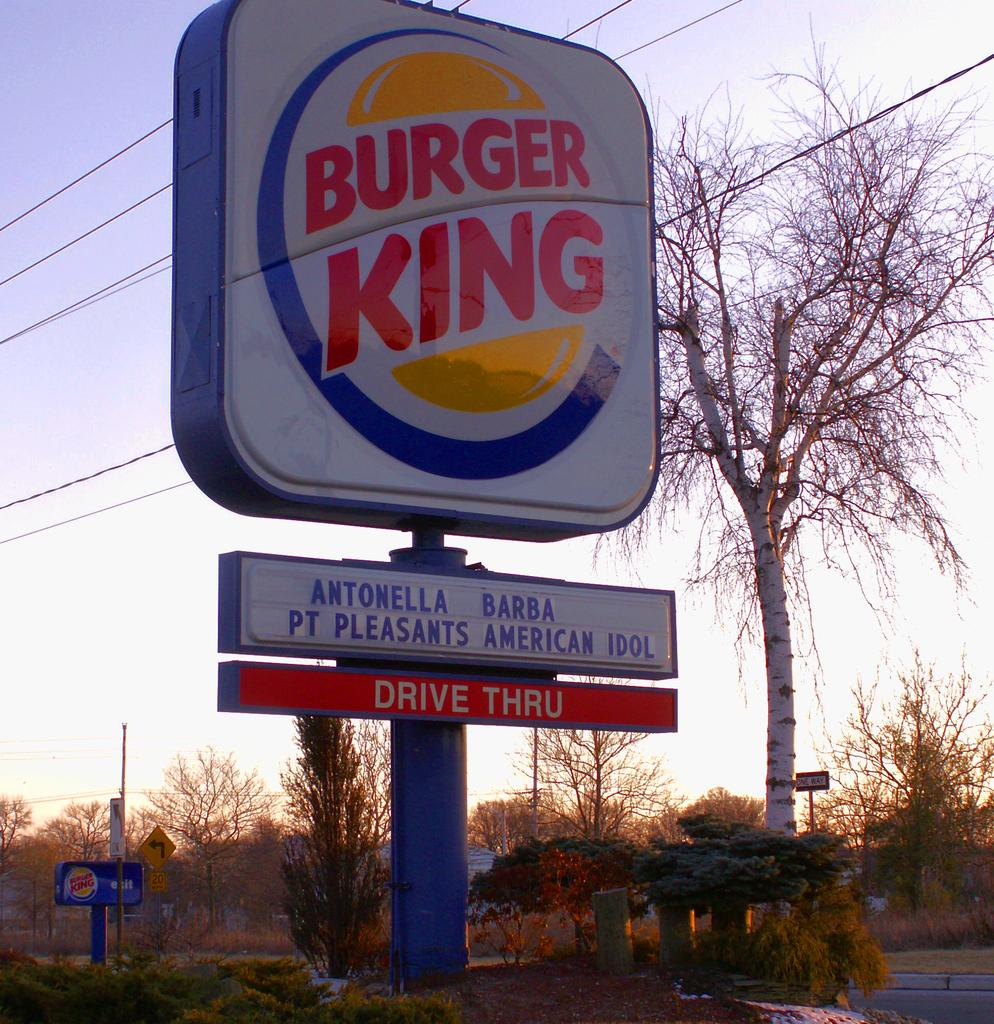What is the main subject of the image? There is a display board of Burger King in the image. What can be seen in the background of the image? There are trees in the background of the image. What else is visible in the image besides the display board and trees? Electrical cables are passing through the top of the image. How many eyes can be seen on the display board of Burger King in the image? There are no eyes present on the display board of Burger King in the image. 